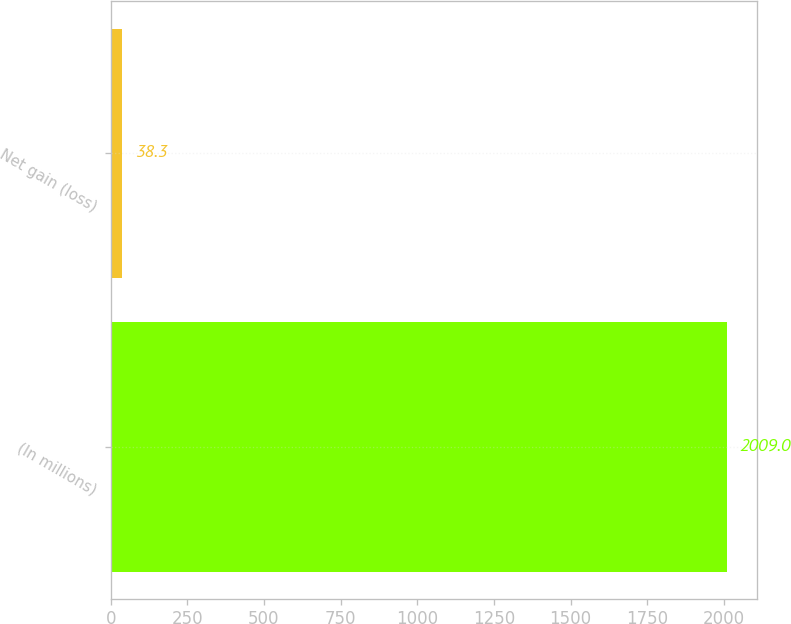Convert chart. <chart><loc_0><loc_0><loc_500><loc_500><bar_chart><fcel>(In millions)<fcel>Net gain (loss)<nl><fcel>2009<fcel>38.3<nl></chart> 